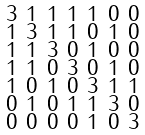<formula> <loc_0><loc_0><loc_500><loc_500>\begin{smallmatrix} 3 & 1 & 1 & 1 & 1 & 0 & 0 \\ 1 & 3 & 1 & 1 & 0 & 1 & 0 \\ 1 & 1 & 3 & 0 & 1 & 0 & 0 \\ 1 & 1 & 0 & 3 & 0 & 1 & 0 \\ 1 & 0 & 1 & 0 & 3 & 1 & 1 \\ 0 & 1 & 0 & 1 & 1 & 3 & 0 \\ 0 & 0 & 0 & 0 & 1 & 0 & 3 \end{smallmatrix}</formula> 